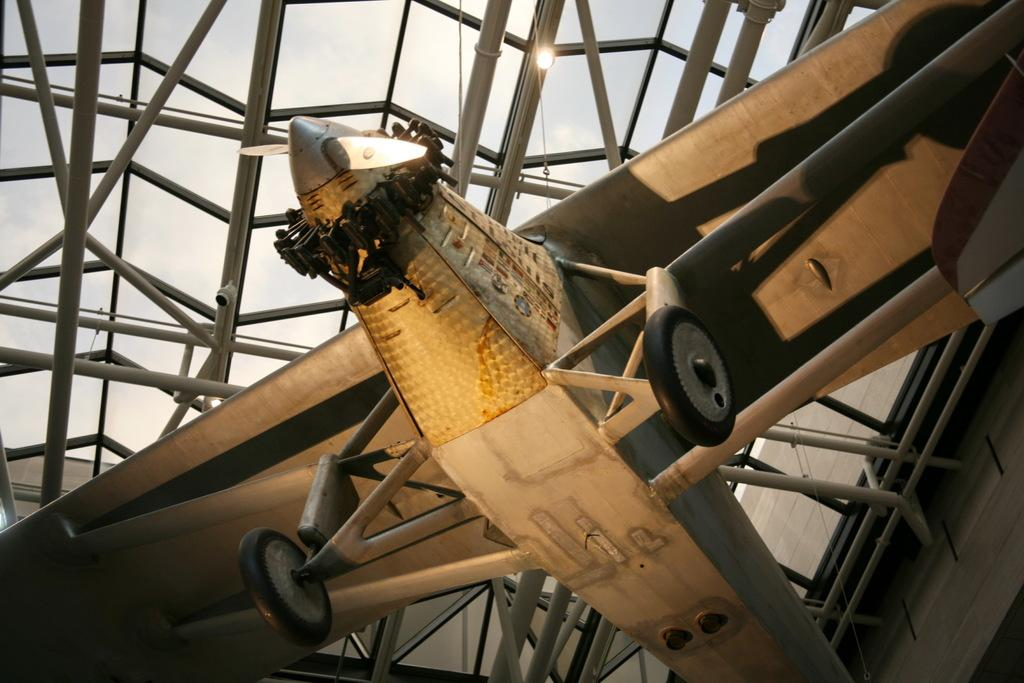What is the main subject of the image? The main subject of the image is an airplane. Where is the airplane located in the image? The airplane is in the middle of the image. What can be seen behind the airplane? There are iron rods visible behind the airplane. What is visible in the background of the image? The sky is visible in the background of the image. What type of rake is being used to prepare the feast in the image? There is no rake or feast present in the image; it features an airplane and iron rods. What key is used to unlock the airplane in the image? There is no key or indication of unlocking in the image; it simply shows an airplane and iron rods. 